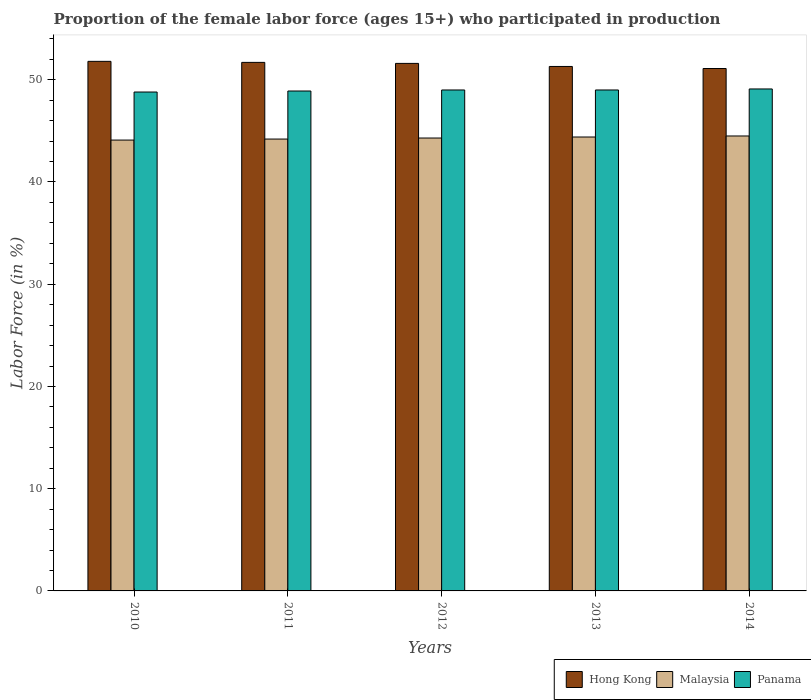How many different coloured bars are there?
Your answer should be very brief. 3. How many groups of bars are there?
Offer a terse response. 5. How many bars are there on the 4th tick from the left?
Your answer should be compact. 3. What is the label of the 5th group of bars from the left?
Your answer should be compact. 2014. What is the proportion of the female labor force who participated in production in Hong Kong in 2011?
Give a very brief answer. 51.7. Across all years, what is the maximum proportion of the female labor force who participated in production in Malaysia?
Keep it short and to the point. 44.5. Across all years, what is the minimum proportion of the female labor force who participated in production in Malaysia?
Your response must be concise. 44.1. In which year was the proportion of the female labor force who participated in production in Malaysia maximum?
Provide a succinct answer. 2014. What is the total proportion of the female labor force who participated in production in Panama in the graph?
Provide a short and direct response. 244.8. What is the difference between the proportion of the female labor force who participated in production in Hong Kong in 2012 and that in 2013?
Ensure brevity in your answer.  0.3. What is the difference between the proportion of the female labor force who participated in production in Hong Kong in 2012 and the proportion of the female labor force who participated in production in Panama in 2013?
Your answer should be compact. 2.6. What is the average proportion of the female labor force who participated in production in Malaysia per year?
Provide a succinct answer. 44.3. In the year 2010, what is the difference between the proportion of the female labor force who participated in production in Hong Kong and proportion of the female labor force who participated in production in Malaysia?
Your answer should be very brief. 7.7. What is the ratio of the proportion of the female labor force who participated in production in Hong Kong in 2012 to that in 2013?
Your response must be concise. 1.01. Is the proportion of the female labor force who participated in production in Hong Kong in 2011 less than that in 2012?
Your response must be concise. No. What is the difference between the highest and the second highest proportion of the female labor force who participated in production in Hong Kong?
Your answer should be compact. 0.1. What is the difference between the highest and the lowest proportion of the female labor force who participated in production in Panama?
Provide a short and direct response. 0.3. Is the sum of the proportion of the female labor force who participated in production in Panama in 2013 and 2014 greater than the maximum proportion of the female labor force who participated in production in Malaysia across all years?
Offer a terse response. Yes. What does the 2nd bar from the left in 2012 represents?
Provide a short and direct response. Malaysia. What does the 3rd bar from the right in 2011 represents?
Give a very brief answer. Hong Kong. Is it the case that in every year, the sum of the proportion of the female labor force who participated in production in Malaysia and proportion of the female labor force who participated in production in Hong Kong is greater than the proportion of the female labor force who participated in production in Panama?
Provide a succinct answer. Yes. How many years are there in the graph?
Give a very brief answer. 5. What is the difference between two consecutive major ticks on the Y-axis?
Offer a terse response. 10. Are the values on the major ticks of Y-axis written in scientific E-notation?
Keep it short and to the point. No. Does the graph contain grids?
Provide a succinct answer. No. How many legend labels are there?
Keep it short and to the point. 3. How are the legend labels stacked?
Provide a short and direct response. Horizontal. What is the title of the graph?
Your response must be concise. Proportion of the female labor force (ages 15+) who participated in production. What is the label or title of the X-axis?
Provide a short and direct response. Years. What is the Labor Force (in %) of Hong Kong in 2010?
Your response must be concise. 51.8. What is the Labor Force (in %) in Malaysia in 2010?
Offer a very short reply. 44.1. What is the Labor Force (in %) in Panama in 2010?
Offer a very short reply. 48.8. What is the Labor Force (in %) of Hong Kong in 2011?
Keep it short and to the point. 51.7. What is the Labor Force (in %) of Malaysia in 2011?
Your answer should be compact. 44.2. What is the Labor Force (in %) in Panama in 2011?
Make the answer very short. 48.9. What is the Labor Force (in %) in Hong Kong in 2012?
Provide a short and direct response. 51.6. What is the Labor Force (in %) in Malaysia in 2012?
Your answer should be very brief. 44.3. What is the Labor Force (in %) of Hong Kong in 2013?
Offer a very short reply. 51.3. What is the Labor Force (in %) of Malaysia in 2013?
Ensure brevity in your answer.  44.4. What is the Labor Force (in %) in Hong Kong in 2014?
Keep it short and to the point. 51.1. What is the Labor Force (in %) in Malaysia in 2014?
Make the answer very short. 44.5. What is the Labor Force (in %) of Panama in 2014?
Offer a terse response. 49.1. Across all years, what is the maximum Labor Force (in %) in Hong Kong?
Make the answer very short. 51.8. Across all years, what is the maximum Labor Force (in %) in Malaysia?
Offer a terse response. 44.5. Across all years, what is the maximum Labor Force (in %) in Panama?
Your answer should be very brief. 49.1. Across all years, what is the minimum Labor Force (in %) of Hong Kong?
Your answer should be compact. 51.1. Across all years, what is the minimum Labor Force (in %) in Malaysia?
Give a very brief answer. 44.1. Across all years, what is the minimum Labor Force (in %) of Panama?
Offer a very short reply. 48.8. What is the total Labor Force (in %) of Hong Kong in the graph?
Your response must be concise. 257.5. What is the total Labor Force (in %) in Malaysia in the graph?
Offer a terse response. 221.5. What is the total Labor Force (in %) of Panama in the graph?
Provide a succinct answer. 244.8. What is the difference between the Labor Force (in %) of Hong Kong in 2010 and that in 2011?
Your answer should be compact. 0.1. What is the difference between the Labor Force (in %) of Hong Kong in 2010 and that in 2012?
Make the answer very short. 0.2. What is the difference between the Labor Force (in %) of Malaysia in 2010 and that in 2012?
Make the answer very short. -0.2. What is the difference between the Labor Force (in %) in Hong Kong in 2010 and that in 2013?
Provide a short and direct response. 0.5. What is the difference between the Labor Force (in %) of Malaysia in 2010 and that in 2013?
Offer a very short reply. -0.3. What is the difference between the Labor Force (in %) in Panama in 2010 and that in 2013?
Provide a short and direct response. -0.2. What is the difference between the Labor Force (in %) in Hong Kong in 2010 and that in 2014?
Keep it short and to the point. 0.7. What is the difference between the Labor Force (in %) in Panama in 2011 and that in 2012?
Your response must be concise. -0.1. What is the difference between the Labor Force (in %) of Hong Kong in 2011 and that in 2014?
Ensure brevity in your answer.  0.6. What is the difference between the Labor Force (in %) in Malaysia in 2011 and that in 2014?
Your answer should be compact. -0.3. What is the difference between the Labor Force (in %) of Panama in 2011 and that in 2014?
Ensure brevity in your answer.  -0.2. What is the difference between the Labor Force (in %) in Hong Kong in 2012 and that in 2013?
Make the answer very short. 0.3. What is the difference between the Labor Force (in %) in Malaysia in 2012 and that in 2013?
Provide a short and direct response. -0.1. What is the difference between the Labor Force (in %) in Panama in 2012 and that in 2013?
Provide a succinct answer. 0. What is the difference between the Labor Force (in %) of Hong Kong in 2012 and that in 2014?
Your answer should be compact. 0.5. What is the difference between the Labor Force (in %) in Malaysia in 2012 and that in 2014?
Provide a succinct answer. -0.2. What is the difference between the Labor Force (in %) in Panama in 2013 and that in 2014?
Your answer should be very brief. -0.1. What is the difference between the Labor Force (in %) in Hong Kong in 2010 and the Labor Force (in %) in Panama in 2011?
Offer a very short reply. 2.9. What is the difference between the Labor Force (in %) in Hong Kong in 2010 and the Labor Force (in %) in Malaysia in 2012?
Make the answer very short. 7.5. What is the difference between the Labor Force (in %) in Malaysia in 2010 and the Labor Force (in %) in Panama in 2013?
Offer a terse response. -4.9. What is the difference between the Labor Force (in %) of Hong Kong in 2010 and the Labor Force (in %) of Malaysia in 2014?
Provide a succinct answer. 7.3. What is the difference between the Labor Force (in %) in Hong Kong in 2010 and the Labor Force (in %) in Panama in 2014?
Your answer should be compact. 2.7. What is the difference between the Labor Force (in %) in Hong Kong in 2011 and the Labor Force (in %) in Panama in 2012?
Provide a short and direct response. 2.7. What is the difference between the Labor Force (in %) of Hong Kong in 2011 and the Labor Force (in %) of Malaysia in 2013?
Give a very brief answer. 7.3. What is the difference between the Labor Force (in %) of Hong Kong in 2011 and the Labor Force (in %) of Malaysia in 2014?
Offer a terse response. 7.2. What is the difference between the Labor Force (in %) of Hong Kong in 2012 and the Labor Force (in %) of Malaysia in 2013?
Offer a terse response. 7.2. What is the difference between the Labor Force (in %) in Hong Kong in 2012 and the Labor Force (in %) in Panama in 2013?
Provide a short and direct response. 2.6. What is the difference between the Labor Force (in %) of Malaysia in 2012 and the Labor Force (in %) of Panama in 2013?
Make the answer very short. -4.7. What is the difference between the Labor Force (in %) in Hong Kong in 2012 and the Labor Force (in %) in Malaysia in 2014?
Offer a very short reply. 7.1. What is the difference between the Labor Force (in %) in Malaysia in 2012 and the Labor Force (in %) in Panama in 2014?
Keep it short and to the point. -4.8. What is the difference between the Labor Force (in %) of Hong Kong in 2013 and the Labor Force (in %) of Panama in 2014?
Give a very brief answer. 2.2. What is the difference between the Labor Force (in %) in Malaysia in 2013 and the Labor Force (in %) in Panama in 2014?
Offer a very short reply. -4.7. What is the average Labor Force (in %) in Hong Kong per year?
Offer a very short reply. 51.5. What is the average Labor Force (in %) of Malaysia per year?
Give a very brief answer. 44.3. What is the average Labor Force (in %) of Panama per year?
Provide a succinct answer. 48.96. In the year 2010, what is the difference between the Labor Force (in %) of Hong Kong and Labor Force (in %) of Malaysia?
Give a very brief answer. 7.7. In the year 2010, what is the difference between the Labor Force (in %) in Hong Kong and Labor Force (in %) in Panama?
Ensure brevity in your answer.  3. In the year 2010, what is the difference between the Labor Force (in %) in Malaysia and Labor Force (in %) in Panama?
Offer a terse response. -4.7. In the year 2011, what is the difference between the Labor Force (in %) in Hong Kong and Labor Force (in %) in Panama?
Keep it short and to the point. 2.8. In the year 2011, what is the difference between the Labor Force (in %) of Malaysia and Labor Force (in %) of Panama?
Provide a short and direct response. -4.7. In the year 2012, what is the difference between the Labor Force (in %) in Hong Kong and Labor Force (in %) in Malaysia?
Keep it short and to the point. 7.3. In the year 2012, what is the difference between the Labor Force (in %) in Hong Kong and Labor Force (in %) in Panama?
Offer a terse response. 2.6. In the year 2013, what is the difference between the Labor Force (in %) of Hong Kong and Labor Force (in %) of Malaysia?
Your response must be concise. 6.9. In the year 2013, what is the difference between the Labor Force (in %) in Hong Kong and Labor Force (in %) in Panama?
Give a very brief answer. 2.3. In the year 2014, what is the difference between the Labor Force (in %) of Hong Kong and Labor Force (in %) of Panama?
Offer a terse response. 2. In the year 2014, what is the difference between the Labor Force (in %) of Malaysia and Labor Force (in %) of Panama?
Your answer should be compact. -4.6. What is the ratio of the Labor Force (in %) in Hong Kong in 2010 to that in 2011?
Provide a short and direct response. 1. What is the ratio of the Labor Force (in %) in Malaysia in 2010 to that in 2011?
Provide a short and direct response. 1. What is the ratio of the Labor Force (in %) in Panama in 2010 to that in 2011?
Ensure brevity in your answer.  1. What is the ratio of the Labor Force (in %) of Hong Kong in 2010 to that in 2012?
Your answer should be very brief. 1. What is the ratio of the Labor Force (in %) in Malaysia in 2010 to that in 2012?
Offer a very short reply. 1. What is the ratio of the Labor Force (in %) in Hong Kong in 2010 to that in 2013?
Your answer should be compact. 1.01. What is the ratio of the Labor Force (in %) in Malaysia in 2010 to that in 2013?
Make the answer very short. 0.99. What is the ratio of the Labor Force (in %) of Panama in 2010 to that in 2013?
Ensure brevity in your answer.  1. What is the ratio of the Labor Force (in %) of Hong Kong in 2010 to that in 2014?
Give a very brief answer. 1.01. What is the ratio of the Labor Force (in %) of Malaysia in 2010 to that in 2014?
Offer a very short reply. 0.99. What is the ratio of the Labor Force (in %) of Panama in 2010 to that in 2014?
Your answer should be very brief. 0.99. What is the ratio of the Labor Force (in %) in Hong Kong in 2011 to that in 2012?
Make the answer very short. 1. What is the ratio of the Labor Force (in %) of Panama in 2011 to that in 2012?
Offer a very short reply. 1. What is the ratio of the Labor Force (in %) in Hong Kong in 2011 to that in 2013?
Offer a terse response. 1.01. What is the ratio of the Labor Force (in %) of Panama in 2011 to that in 2013?
Make the answer very short. 1. What is the ratio of the Labor Force (in %) in Hong Kong in 2011 to that in 2014?
Give a very brief answer. 1.01. What is the ratio of the Labor Force (in %) of Malaysia in 2011 to that in 2014?
Make the answer very short. 0.99. What is the ratio of the Labor Force (in %) of Panama in 2011 to that in 2014?
Your answer should be very brief. 1. What is the ratio of the Labor Force (in %) in Hong Kong in 2012 to that in 2013?
Provide a succinct answer. 1.01. What is the ratio of the Labor Force (in %) of Panama in 2012 to that in 2013?
Give a very brief answer. 1. What is the ratio of the Labor Force (in %) of Hong Kong in 2012 to that in 2014?
Keep it short and to the point. 1.01. What is the ratio of the Labor Force (in %) of Malaysia in 2012 to that in 2014?
Your answer should be compact. 1. What is the ratio of the Labor Force (in %) in Panama in 2012 to that in 2014?
Provide a succinct answer. 1. What is the ratio of the Labor Force (in %) of Hong Kong in 2013 to that in 2014?
Provide a succinct answer. 1. What is the difference between the highest and the second highest Labor Force (in %) in Hong Kong?
Give a very brief answer. 0.1. What is the difference between the highest and the lowest Labor Force (in %) of Panama?
Offer a terse response. 0.3. 